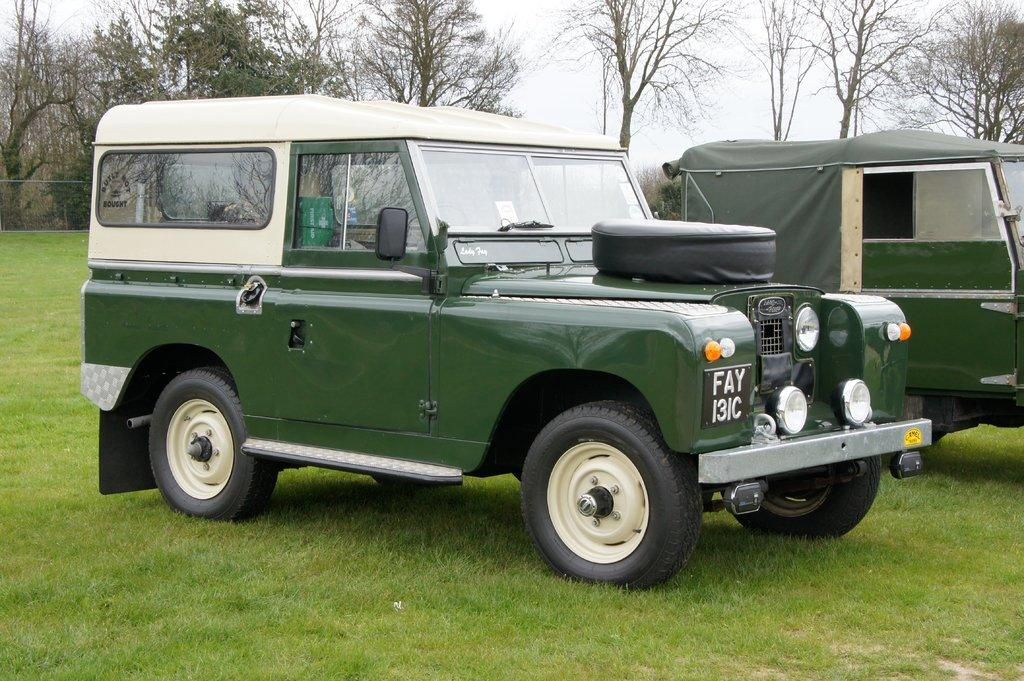How many vehicles are present in the image? There are two jeeps in the image. What type of terrain are the jeeps on? The jeeps are on the surface of the grass. What can be seen in the background of the image? There are trees in the background of the image. What is the grade of the moon in the image? There is no moon present in the image, so it is not possible to determine its grade. 